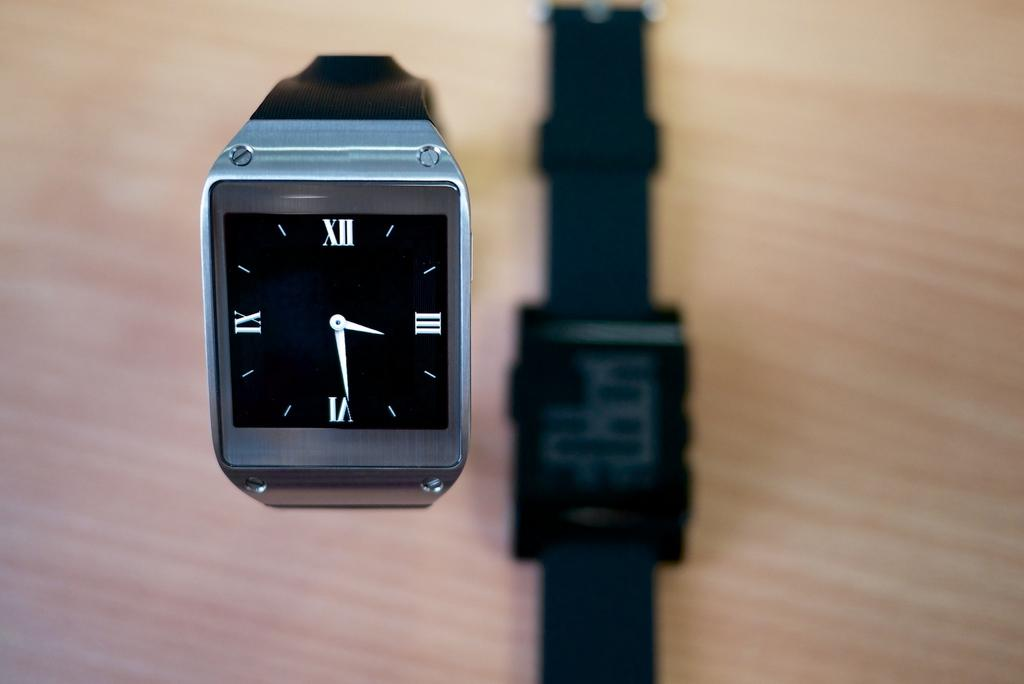<image>
Provide a brief description of the given image. The black and silver watch shows the time 3:29 and has the reverse side showing on the table. 